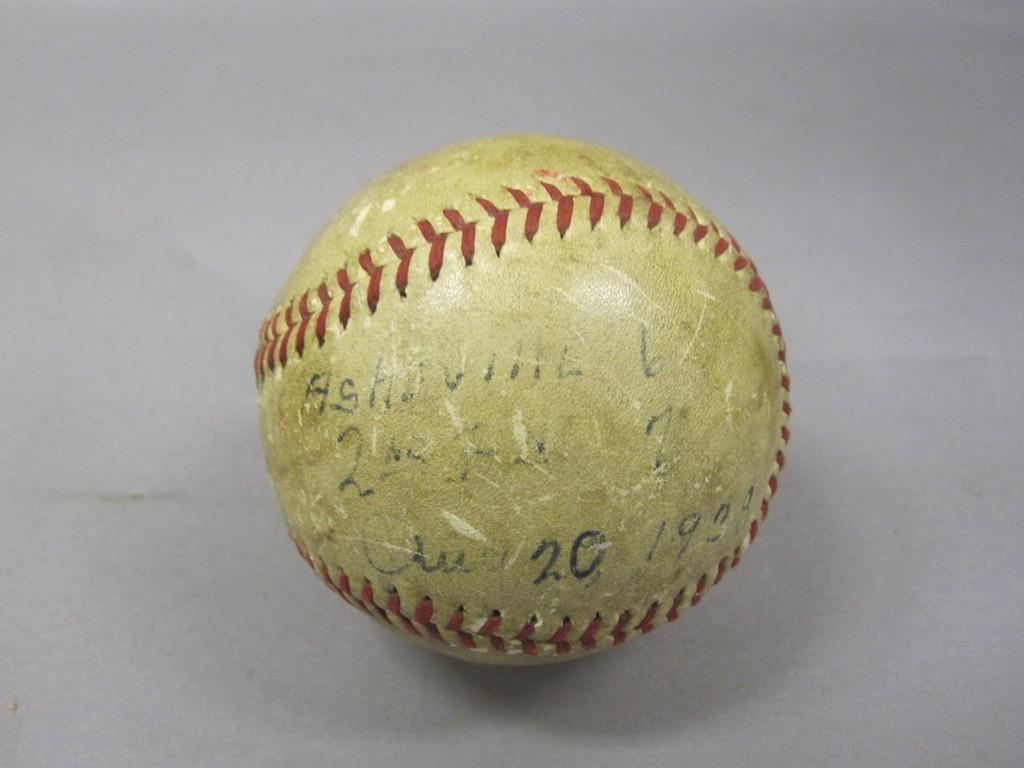Please provide a concise description of this image. There is a ball, on which there are some designs and texts. This ball is placed on a white colored surface. 